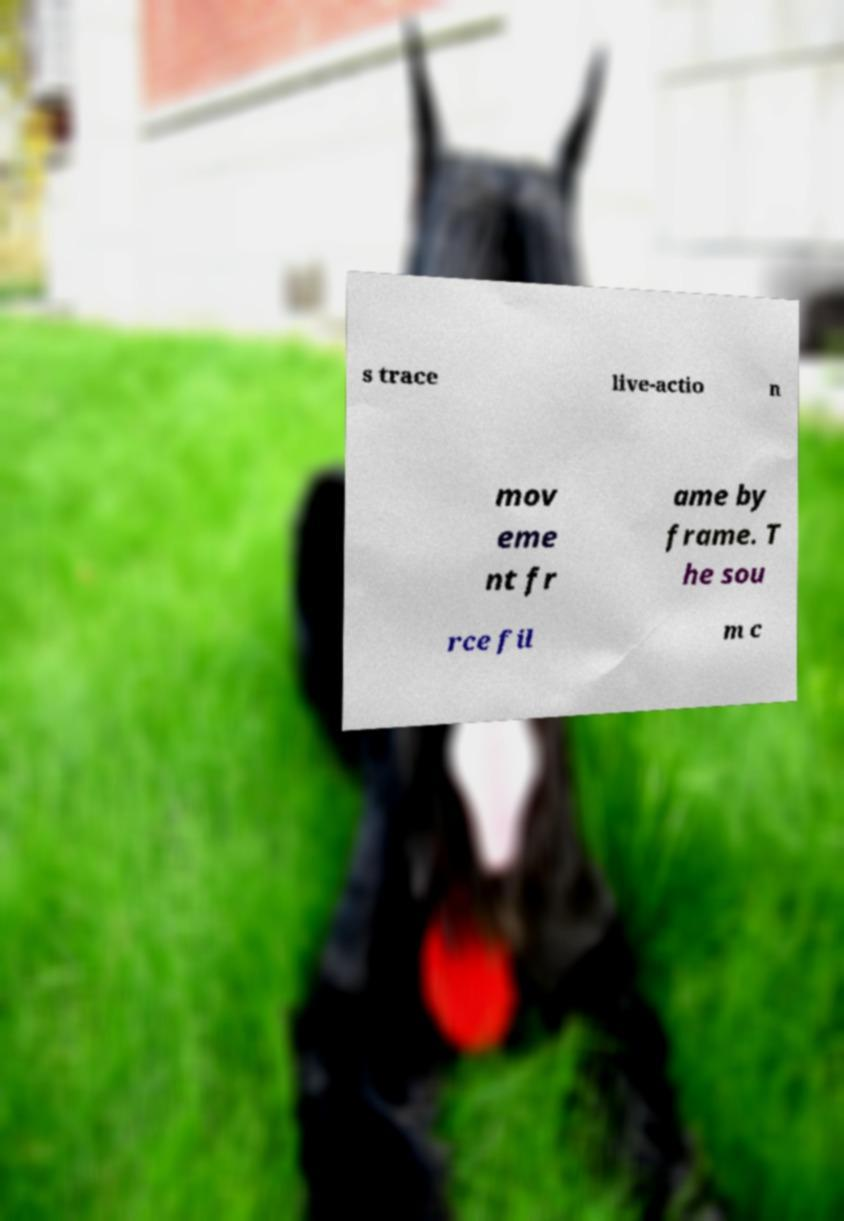Can you accurately transcribe the text from the provided image for me? s trace live-actio n mov eme nt fr ame by frame. T he sou rce fil m c 